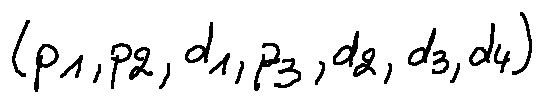<formula> <loc_0><loc_0><loc_500><loc_500>( p _ { 1 } , p _ { 2 } , d _ { 1 } , p _ { 3 } , d _ { 2 } , d _ { 3 } , d _ { 4 } )</formula> 